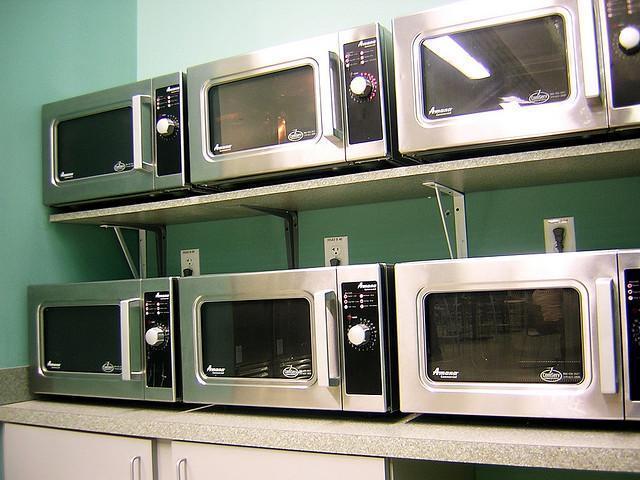Why are there so many microwaves?
Answer the question by selecting the correct answer among the 4 following choices and explain your choice with a short sentence. The answer should be formatted with the following format: `Answer: choice
Rationale: rationale.`
Options: Are stolen, for sale, hiding them, many users. Answer: for sale.
Rationale: The microwaves are lined up and plugged in for trial. 